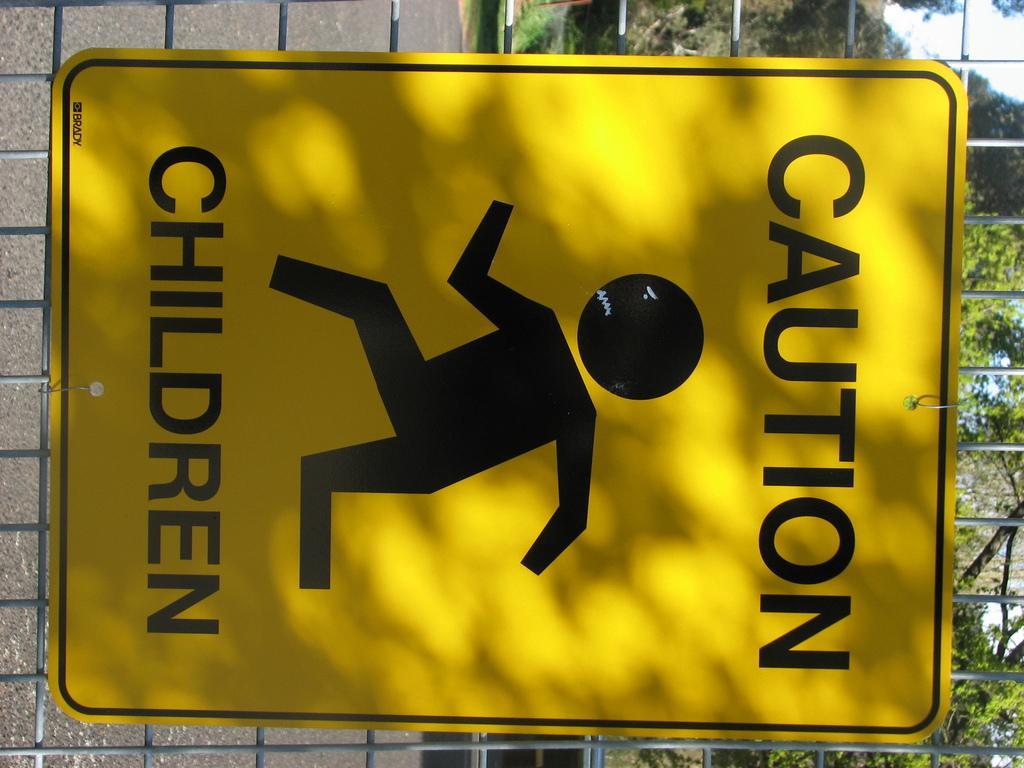In one or two sentences, can you explain what this image depicts? In the foreground of the picture there is a board on the fencing. In the background there are trees and wall. 